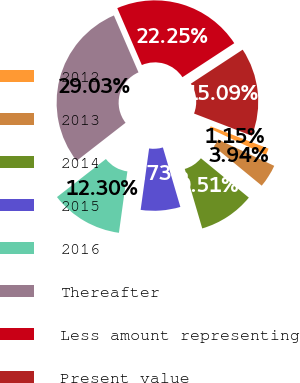<chart> <loc_0><loc_0><loc_500><loc_500><pie_chart><fcel>2012<fcel>2013<fcel>2014<fcel>2015<fcel>2016<fcel>Thereafter<fcel>Less amount representing<fcel>Present value<nl><fcel>1.15%<fcel>3.94%<fcel>9.51%<fcel>6.73%<fcel>12.3%<fcel>29.03%<fcel>22.25%<fcel>15.09%<nl></chart> 